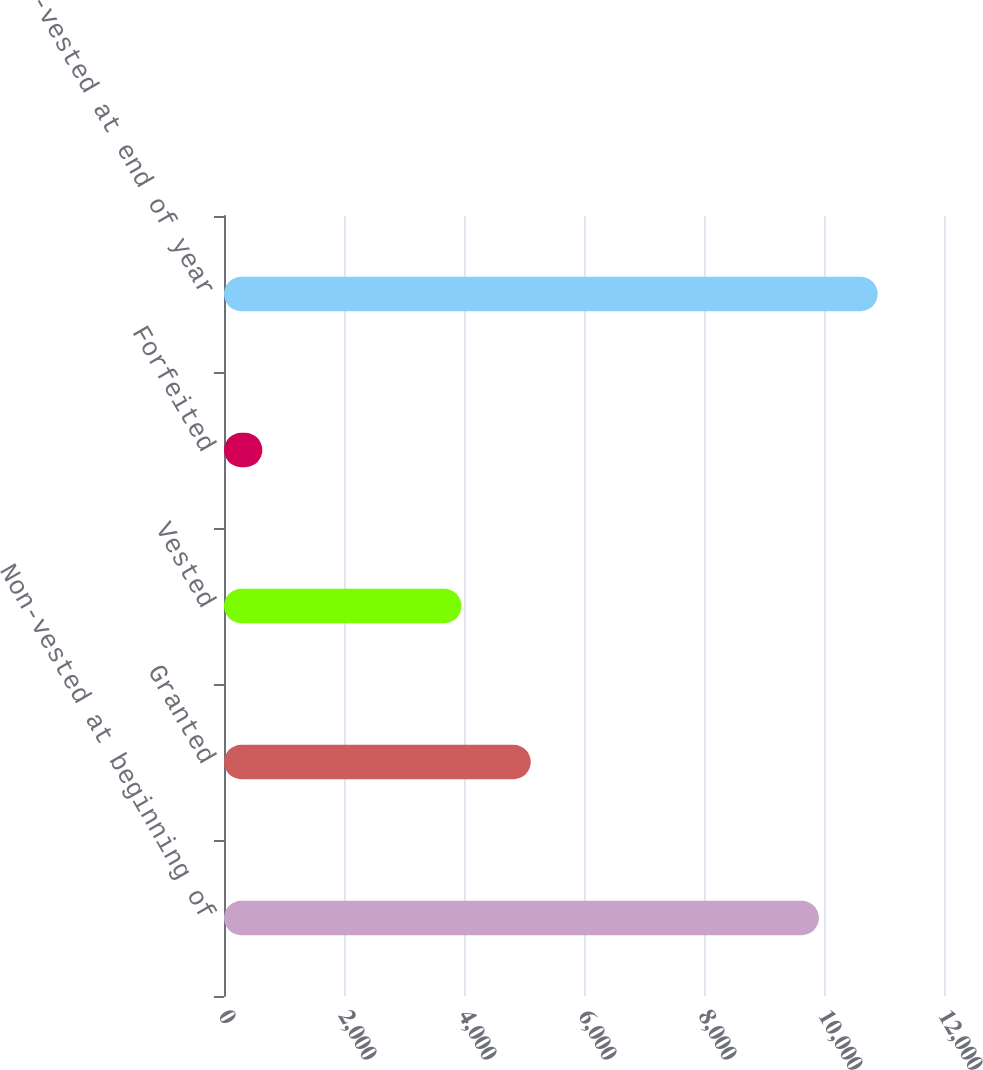<chart> <loc_0><loc_0><loc_500><loc_500><bar_chart><fcel>Non-vested at beginning of<fcel>Granted<fcel>Vested<fcel>Forfeited<fcel>Non-vested at end of year<nl><fcel>9916<fcel>5113<fcel>3958<fcel>639<fcel>10895.3<nl></chart> 